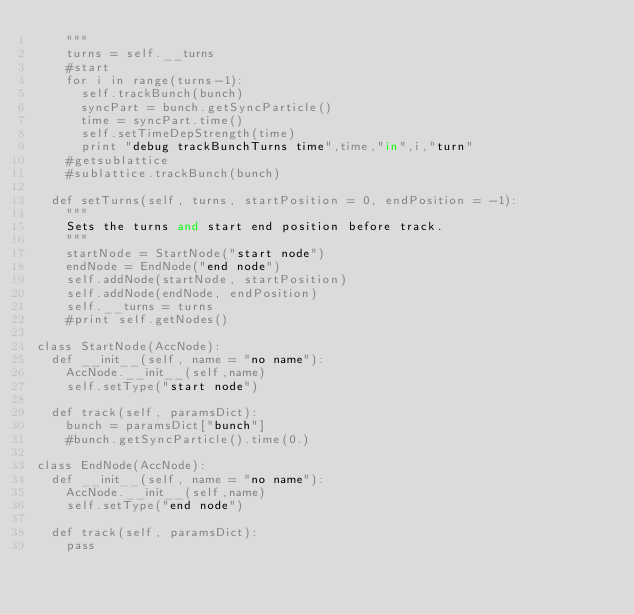<code> <loc_0><loc_0><loc_500><loc_500><_Python_>		"""
		turns = self.__turns
		#start
		for i in range(turns-1):			
			self.trackBunch(bunch)	
			syncPart = bunch.getSyncParticle()
			time = syncPart.time()
			self.setTimeDepStrength(time)
			print "debug trackBunchTurns time",time,"in",i,"turn"
		#getsublattice
		#sublattice.trackBunch(bunch)
		
	def setTurns(self, turns, startPosition = 0, endPosition = -1):
		"""
		Sets the turns and start end position before track.
		"""
		startNode = StartNode("start node")
		endNode = EndNode("end node")	
		self.addNode(startNode, startPosition)
		self.addNode(endNode, endPosition)
		self.__turns = turns	
		#print self.getNodes()

class StartNode(AccNode):
	def __init__(self, name = "no name"):
		AccNode.__init__(self,name)
		self.setType("start node")
		
	def track(self, paramsDict):
		bunch = paramsDict["bunch"]
		#bunch.getSyncParticle().time(0.)		
		
class EndNode(AccNode):
	def __init__(self, name = "no name"):
		AccNode.__init__(self,name)
		self.setType("end node")
		
	def track(self, paramsDict):
		pass
</code> 